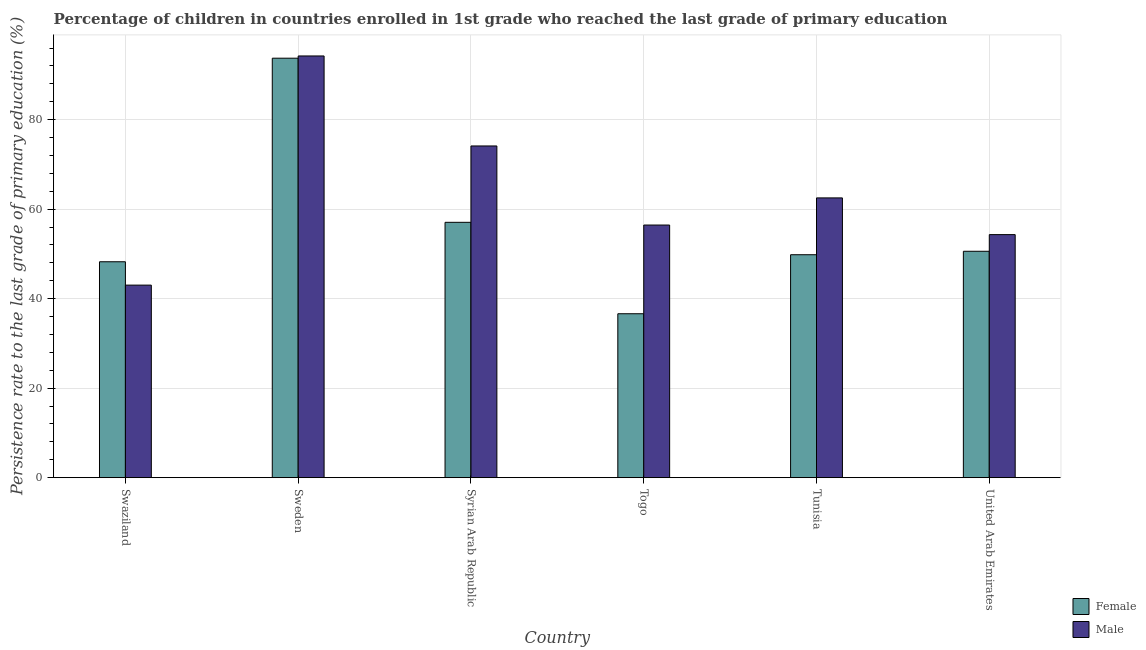Are the number of bars per tick equal to the number of legend labels?
Offer a terse response. Yes. How many bars are there on the 6th tick from the left?
Your response must be concise. 2. How many bars are there on the 5th tick from the right?
Give a very brief answer. 2. What is the label of the 5th group of bars from the left?
Your response must be concise. Tunisia. What is the persistence rate of male students in Syrian Arab Republic?
Ensure brevity in your answer.  74.12. Across all countries, what is the maximum persistence rate of male students?
Offer a terse response. 94.23. Across all countries, what is the minimum persistence rate of female students?
Your answer should be very brief. 36.63. In which country was the persistence rate of female students maximum?
Offer a terse response. Sweden. In which country was the persistence rate of male students minimum?
Keep it short and to the point. Swaziland. What is the total persistence rate of female students in the graph?
Provide a succinct answer. 336.05. What is the difference between the persistence rate of female students in Togo and that in Tunisia?
Your answer should be compact. -13.19. What is the difference between the persistence rate of male students in United Arab Emirates and the persistence rate of female students in Tunisia?
Keep it short and to the point. 4.49. What is the average persistence rate of female students per country?
Keep it short and to the point. 56.01. What is the difference between the persistence rate of male students and persistence rate of female students in Swaziland?
Your answer should be very brief. -5.22. What is the ratio of the persistence rate of female students in Syrian Arab Republic to that in Tunisia?
Offer a very short reply. 1.15. What is the difference between the highest and the second highest persistence rate of male students?
Make the answer very short. 20.11. What is the difference between the highest and the lowest persistence rate of male students?
Offer a terse response. 51.21. What does the 1st bar from the left in Swaziland represents?
Make the answer very short. Female. What does the 1st bar from the right in Tunisia represents?
Offer a terse response. Male. Are all the bars in the graph horizontal?
Provide a succinct answer. No. How many countries are there in the graph?
Your answer should be very brief. 6. Are the values on the major ticks of Y-axis written in scientific E-notation?
Provide a succinct answer. No. How are the legend labels stacked?
Your response must be concise. Vertical. What is the title of the graph?
Make the answer very short. Percentage of children in countries enrolled in 1st grade who reached the last grade of primary education. Does "Register a property" appear as one of the legend labels in the graph?
Provide a short and direct response. No. What is the label or title of the X-axis?
Provide a short and direct response. Country. What is the label or title of the Y-axis?
Provide a short and direct response. Persistence rate to the last grade of primary education (%). What is the Persistence rate to the last grade of primary education (%) of Female in Swaziland?
Your response must be concise. 48.24. What is the Persistence rate to the last grade of primary education (%) of Male in Swaziland?
Provide a short and direct response. 43.02. What is the Persistence rate to the last grade of primary education (%) of Female in Sweden?
Give a very brief answer. 93.73. What is the Persistence rate to the last grade of primary education (%) in Male in Sweden?
Ensure brevity in your answer.  94.23. What is the Persistence rate to the last grade of primary education (%) in Female in Syrian Arab Republic?
Provide a short and direct response. 57.06. What is the Persistence rate to the last grade of primary education (%) of Male in Syrian Arab Republic?
Provide a short and direct response. 74.12. What is the Persistence rate to the last grade of primary education (%) of Female in Togo?
Provide a succinct answer. 36.63. What is the Persistence rate to the last grade of primary education (%) in Male in Togo?
Provide a short and direct response. 56.45. What is the Persistence rate to the last grade of primary education (%) in Female in Tunisia?
Offer a very short reply. 49.81. What is the Persistence rate to the last grade of primary education (%) in Male in Tunisia?
Offer a very short reply. 62.51. What is the Persistence rate to the last grade of primary education (%) in Female in United Arab Emirates?
Give a very brief answer. 50.58. What is the Persistence rate to the last grade of primary education (%) of Male in United Arab Emirates?
Make the answer very short. 54.31. Across all countries, what is the maximum Persistence rate to the last grade of primary education (%) of Female?
Offer a terse response. 93.73. Across all countries, what is the maximum Persistence rate to the last grade of primary education (%) of Male?
Provide a succinct answer. 94.23. Across all countries, what is the minimum Persistence rate to the last grade of primary education (%) of Female?
Offer a terse response. 36.63. Across all countries, what is the minimum Persistence rate to the last grade of primary education (%) in Male?
Your answer should be compact. 43.02. What is the total Persistence rate to the last grade of primary education (%) of Female in the graph?
Provide a succinct answer. 336.05. What is the total Persistence rate to the last grade of primary education (%) of Male in the graph?
Provide a succinct answer. 384.64. What is the difference between the Persistence rate to the last grade of primary education (%) in Female in Swaziland and that in Sweden?
Your answer should be compact. -45.49. What is the difference between the Persistence rate to the last grade of primary education (%) in Male in Swaziland and that in Sweden?
Provide a short and direct response. -51.21. What is the difference between the Persistence rate to the last grade of primary education (%) in Female in Swaziland and that in Syrian Arab Republic?
Your answer should be compact. -8.81. What is the difference between the Persistence rate to the last grade of primary education (%) in Male in Swaziland and that in Syrian Arab Republic?
Keep it short and to the point. -31.1. What is the difference between the Persistence rate to the last grade of primary education (%) of Female in Swaziland and that in Togo?
Your answer should be compact. 11.62. What is the difference between the Persistence rate to the last grade of primary education (%) in Male in Swaziland and that in Togo?
Keep it short and to the point. -13.42. What is the difference between the Persistence rate to the last grade of primary education (%) in Female in Swaziland and that in Tunisia?
Your answer should be compact. -1.57. What is the difference between the Persistence rate to the last grade of primary education (%) of Male in Swaziland and that in Tunisia?
Your response must be concise. -19.49. What is the difference between the Persistence rate to the last grade of primary education (%) in Female in Swaziland and that in United Arab Emirates?
Offer a very short reply. -2.34. What is the difference between the Persistence rate to the last grade of primary education (%) of Male in Swaziland and that in United Arab Emirates?
Your response must be concise. -11.29. What is the difference between the Persistence rate to the last grade of primary education (%) of Female in Sweden and that in Syrian Arab Republic?
Provide a short and direct response. 36.68. What is the difference between the Persistence rate to the last grade of primary education (%) in Male in Sweden and that in Syrian Arab Republic?
Offer a very short reply. 20.11. What is the difference between the Persistence rate to the last grade of primary education (%) in Female in Sweden and that in Togo?
Offer a very short reply. 57.11. What is the difference between the Persistence rate to the last grade of primary education (%) in Male in Sweden and that in Togo?
Keep it short and to the point. 37.78. What is the difference between the Persistence rate to the last grade of primary education (%) of Female in Sweden and that in Tunisia?
Your answer should be very brief. 43.92. What is the difference between the Persistence rate to the last grade of primary education (%) in Male in Sweden and that in Tunisia?
Ensure brevity in your answer.  31.72. What is the difference between the Persistence rate to the last grade of primary education (%) in Female in Sweden and that in United Arab Emirates?
Keep it short and to the point. 43.15. What is the difference between the Persistence rate to the last grade of primary education (%) in Male in Sweden and that in United Arab Emirates?
Provide a succinct answer. 39.92. What is the difference between the Persistence rate to the last grade of primary education (%) of Female in Syrian Arab Republic and that in Togo?
Your response must be concise. 20.43. What is the difference between the Persistence rate to the last grade of primary education (%) in Male in Syrian Arab Republic and that in Togo?
Keep it short and to the point. 17.67. What is the difference between the Persistence rate to the last grade of primary education (%) in Female in Syrian Arab Republic and that in Tunisia?
Provide a succinct answer. 7.24. What is the difference between the Persistence rate to the last grade of primary education (%) of Male in Syrian Arab Republic and that in Tunisia?
Make the answer very short. 11.61. What is the difference between the Persistence rate to the last grade of primary education (%) in Female in Syrian Arab Republic and that in United Arab Emirates?
Your answer should be very brief. 6.47. What is the difference between the Persistence rate to the last grade of primary education (%) in Male in Syrian Arab Republic and that in United Arab Emirates?
Ensure brevity in your answer.  19.81. What is the difference between the Persistence rate to the last grade of primary education (%) of Female in Togo and that in Tunisia?
Offer a very short reply. -13.19. What is the difference between the Persistence rate to the last grade of primary education (%) of Male in Togo and that in Tunisia?
Your response must be concise. -6.07. What is the difference between the Persistence rate to the last grade of primary education (%) of Female in Togo and that in United Arab Emirates?
Your response must be concise. -13.96. What is the difference between the Persistence rate to the last grade of primary education (%) in Male in Togo and that in United Arab Emirates?
Offer a very short reply. 2.14. What is the difference between the Persistence rate to the last grade of primary education (%) in Female in Tunisia and that in United Arab Emirates?
Ensure brevity in your answer.  -0.77. What is the difference between the Persistence rate to the last grade of primary education (%) of Male in Tunisia and that in United Arab Emirates?
Your answer should be very brief. 8.21. What is the difference between the Persistence rate to the last grade of primary education (%) of Female in Swaziland and the Persistence rate to the last grade of primary education (%) of Male in Sweden?
Provide a succinct answer. -45.99. What is the difference between the Persistence rate to the last grade of primary education (%) in Female in Swaziland and the Persistence rate to the last grade of primary education (%) in Male in Syrian Arab Republic?
Offer a very short reply. -25.88. What is the difference between the Persistence rate to the last grade of primary education (%) of Female in Swaziland and the Persistence rate to the last grade of primary education (%) of Male in Togo?
Offer a terse response. -8.2. What is the difference between the Persistence rate to the last grade of primary education (%) in Female in Swaziland and the Persistence rate to the last grade of primary education (%) in Male in Tunisia?
Your answer should be very brief. -14.27. What is the difference between the Persistence rate to the last grade of primary education (%) in Female in Swaziland and the Persistence rate to the last grade of primary education (%) in Male in United Arab Emirates?
Ensure brevity in your answer.  -6.06. What is the difference between the Persistence rate to the last grade of primary education (%) of Female in Sweden and the Persistence rate to the last grade of primary education (%) of Male in Syrian Arab Republic?
Give a very brief answer. 19.61. What is the difference between the Persistence rate to the last grade of primary education (%) in Female in Sweden and the Persistence rate to the last grade of primary education (%) in Male in Togo?
Your response must be concise. 37.29. What is the difference between the Persistence rate to the last grade of primary education (%) in Female in Sweden and the Persistence rate to the last grade of primary education (%) in Male in Tunisia?
Offer a terse response. 31.22. What is the difference between the Persistence rate to the last grade of primary education (%) in Female in Sweden and the Persistence rate to the last grade of primary education (%) in Male in United Arab Emirates?
Ensure brevity in your answer.  39.43. What is the difference between the Persistence rate to the last grade of primary education (%) in Female in Syrian Arab Republic and the Persistence rate to the last grade of primary education (%) in Male in Togo?
Provide a short and direct response. 0.61. What is the difference between the Persistence rate to the last grade of primary education (%) of Female in Syrian Arab Republic and the Persistence rate to the last grade of primary education (%) of Male in Tunisia?
Your answer should be very brief. -5.46. What is the difference between the Persistence rate to the last grade of primary education (%) in Female in Syrian Arab Republic and the Persistence rate to the last grade of primary education (%) in Male in United Arab Emirates?
Provide a short and direct response. 2.75. What is the difference between the Persistence rate to the last grade of primary education (%) in Female in Togo and the Persistence rate to the last grade of primary education (%) in Male in Tunisia?
Give a very brief answer. -25.89. What is the difference between the Persistence rate to the last grade of primary education (%) of Female in Togo and the Persistence rate to the last grade of primary education (%) of Male in United Arab Emirates?
Offer a very short reply. -17.68. What is the difference between the Persistence rate to the last grade of primary education (%) in Female in Tunisia and the Persistence rate to the last grade of primary education (%) in Male in United Arab Emirates?
Your answer should be very brief. -4.49. What is the average Persistence rate to the last grade of primary education (%) in Female per country?
Offer a very short reply. 56.01. What is the average Persistence rate to the last grade of primary education (%) in Male per country?
Your answer should be very brief. 64.11. What is the difference between the Persistence rate to the last grade of primary education (%) in Female and Persistence rate to the last grade of primary education (%) in Male in Swaziland?
Your answer should be very brief. 5.22. What is the difference between the Persistence rate to the last grade of primary education (%) of Female and Persistence rate to the last grade of primary education (%) of Male in Sweden?
Ensure brevity in your answer.  -0.5. What is the difference between the Persistence rate to the last grade of primary education (%) in Female and Persistence rate to the last grade of primary education (%) in Male in Syrian Arab Republic?
Offer a very short reply. -17.06. What is the difference between the Persistence rate to the last grade of primary education (%) in Female and Persistence rate to the last grade of primary education (%) in Male in Togo?
Make the answer very short. -19.82. What is the difference between the Persistence rate to the last grade of primary education (%) in Female and Persistence rate to the last grade of primary education (%) in Male in Tunisia?
Offer a very short reply. -12.7. What is the difference between the Persistence rate to the last grade of primary education (%) of Female and Persistence rate to the last grade of primary education (%) of Male in United Arab Emirates?
Keep it short and to the point. -3.72. What is the ratio of the Persistence rate to the last grade of primary education (%) of Female in Swaziland to that in Sweden?
Provide a succinct answer. 0.51. What is the ratio of the Persistence rate to the last grade of primary education (%) of Male in Swaziland to that in Sweden?
Give a very brief answer. 0.46. What is the ratio of the Persistence rate to the last grade of primary education (%) in Female in Swaziland to that in Syrian Arab Republic?
Keep it short and to the point. 0.85. What is the ratio of the Persistence rate to the last grade of primary education (%) in Male in Swaziland to that in Syrian Arab Republic?
Make the answer very short. 0.58. What is the ratio of the Persistence rate to the last grade of primary education (%) of Female in Swaziland to that in Togo?
Your response must be concise. 1.32. What is the ratio of the Persistence rate to the last grade of primary education (%) in Male in Swaziland to that in Togo?
Make the answer very short. 0.76. What is the ratio of the Persistence rate to the last grade of primary education (%) of Female in Swaziland to that in Tunisia?
Your answer should be compact. 0.97. What is the ratio of the Persistence rate to the last grade of primary education (%) of Male in Swaziland to that in Tunisia?
Make the answer very short. 0.69. What is the ratio of the Persistence rate to the last grade of primary education (%) in Female in Swaziland to that in United Arab Emirates?
Your answer should be compact. 0.95. What is the ratio of the Persistence rate to the last grade of primary education (%) of Male in Swaziland to that in United Arab Emirates?
Your answer should be compact. 0.79. What is the ratio of the Persistence rate to the last grade of primary education (%) of Female in Sweden to that in Syrian Arab Republic?
Provide a short and direct response. 1.64. What is the ratio of the Persistence rate to the last grade of primary education (%) of Male in Sweden to that in Syrian Arab Republic?
Your response must be concise. 1.27. What is the ratio of the Persistence rate to the last grade of primary education (%) in Female in Sweden to that in Togo?
Provide a succinct answer. 2.56. What is the ratio of the Persistence rate to the last grade of primary education (%) in Male in Sweden to that in Togo?
Give a very brief answer. 1.67. What is the ratio of the Persistence rate to the last grade of primary education (%) of Female in Sweden to that in Tunisia?
Your response must be concise. 1.88. What is the ratio of the Persistence rate to the last grade of primary education (%) of Male in Sweden to that in Tunisia?
Give a very brief answer. 1.51. What is the ratio of the Persistence rate to the last grade of primary education (%) of Female in Sweden to that in United Arab Emirates?
Make the answer very short. 1.85. What is the ratio of the Persistence rate to the last grade of primary education (%) in Male in Sweden to that in United Arab Emirates?
Offer a very short reply. 1.74. What is the ratio of the Persistence rate to the last grade of primary education (%) in Female in Syrian Arab Republic to that in Togo?
Give a very brief answer. 1.56. What is the ratio of the Persistence rate to the last grade of primary education (%) of Male in Syrian Arab Republic to that in Togo?
Your answer should be very brief. 1.31. What is the ratio of the Persistence rate to the last grade of primary education (%) of Female in Syrian Arab Republic to that in Tunisia?
Provide a short and direct response. 1.15. What is the ratio of the Persistence rate to the last grade of primary education (%) of Male in Syrian Arab Republic to that in Tunisia?
Your answer should be compact. 1.19. What is the ratio of the Persistence rate to the last grade of primary education (%) in Female in Syrian Arab Republic to that in United Arab Emirates?
Keep it short and to the point. 1.13. What is the ratio of the Persistence rate to the last grade of primary education (%) in Male in Syrian Arab Republic to that in United Arab Emirates?
Ensure brevity in your answer.  1.36. What is the ratio of the Persistence rate to the last grade of primary education (%) of Female in Togo to that in Tunisia?
Your response must be concise. 0.74. What is the ratio of the Persistence rate to the last grade of primary education (%) of Male in Togo to that in Tunisia?
Give a very brief answer. 0.9. What is the ratio of the Persistence rate to the last grade of primary education (%) of Female in Togo to that in United Arab Emirates?
Your answer should be very brief. 0.72. What is the ratio of the Persistence rate to the last grade of primary education (%) of Male in Togo to that in United Arab Emirates?
Your response must be concise. 1.04. What is the ratio of the Persistence rate to the last grade of primary education (%) in Female in Tunisia to that in United Arab Emirates?
Your response must be concise. 0.98. What is the ratio of the Persistence rate to the last grade of primary education (%) in Male in Tunisia to that in United Arab Emirates?
Your answer should be very brief. 1.15. What is the difference between the highest and the second highest Persistence rate to the last grade of primary education (%) in Female?
Provide a short and direct response. 36.68. What is the difference between the highest and the second highest Persistence rate to the last grade of primary education (%) in Male?
Provide a short and direct response. 20.11. What is the difference between the highest and the lowest Persistence rate to the last grade of primary education (%) in Female?
Your answer should be compact. 57.11. What is the difference between the highest and the lowest Persistence rate to the last grade of primary education (%) of Male?
Keep it short and to the point. 51.21. 